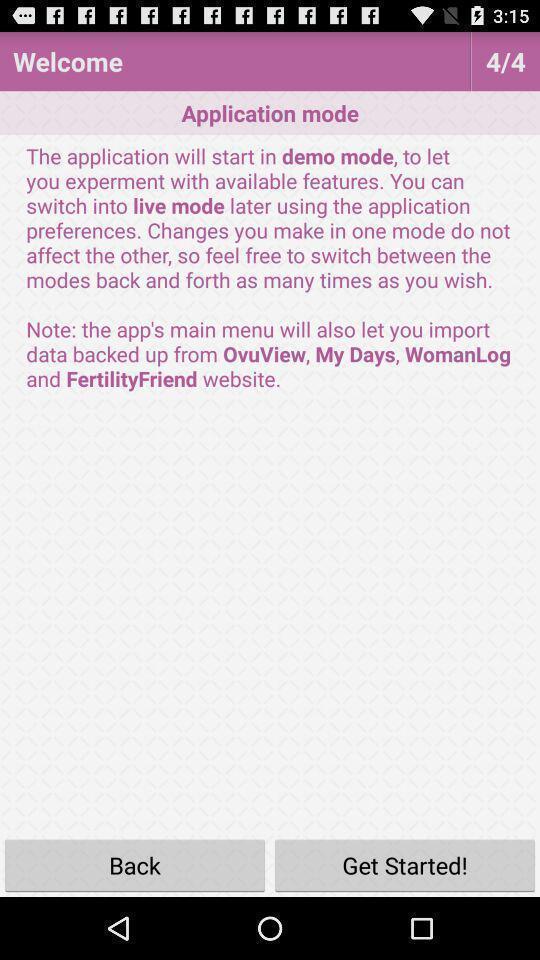Explain what's happening in this screen capture. Welcome page. 